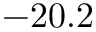<formula> <loc_0><loc_0><loc_500><loc_500>- 2 0 . 2</formula> 